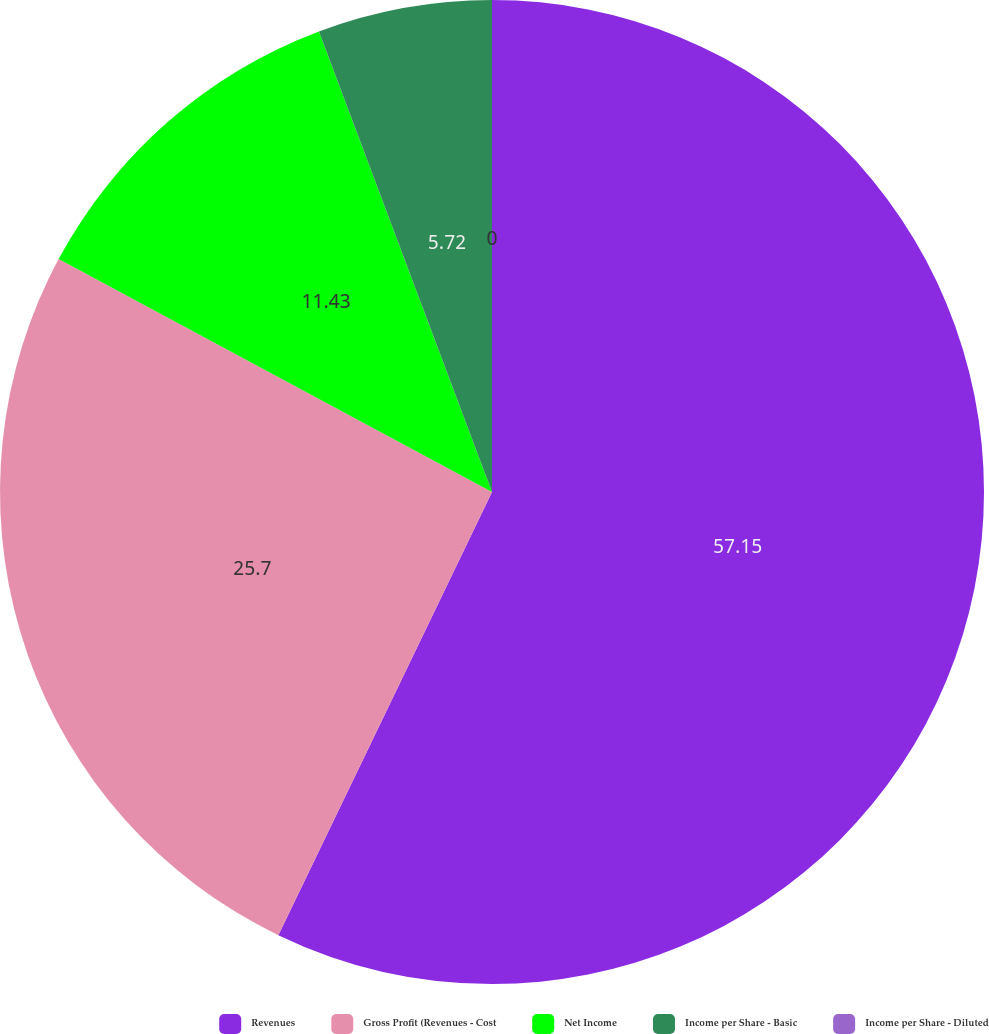Convert chart to OTSL. <chart><loc_0><loc_0><loc_500><loc_500><pie_chart><fcel>Revenues<fcel>Gross Profit (Revenues - Cost<fcel>Net Income<fcel>Income per Share - Basic<fcel>Income per Share - Diluted<nl><fcel>57.15%<fcel>25.7%<fcel>11.43%<fcel>5.72%<fcel>0.0%<nl></chart> 